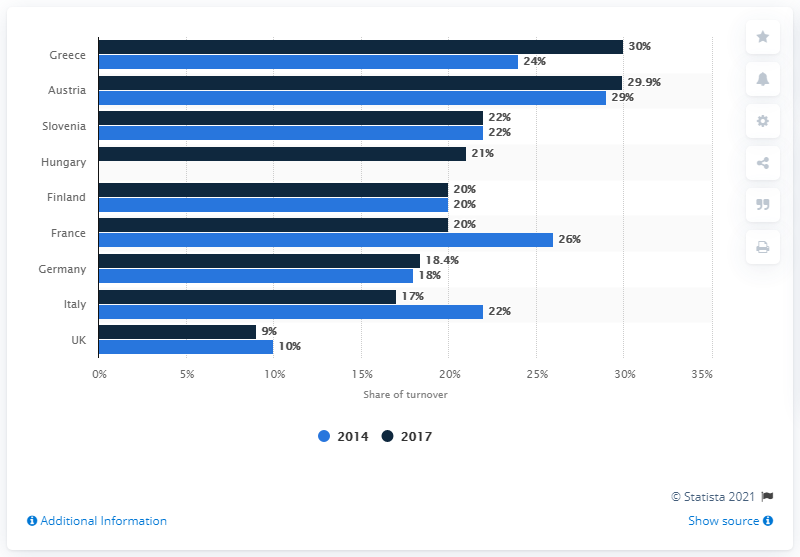Point out several critical features in this image. In 2017, the percentage of total MC turnover attributable to strategy services in Germany was 18.4%. 